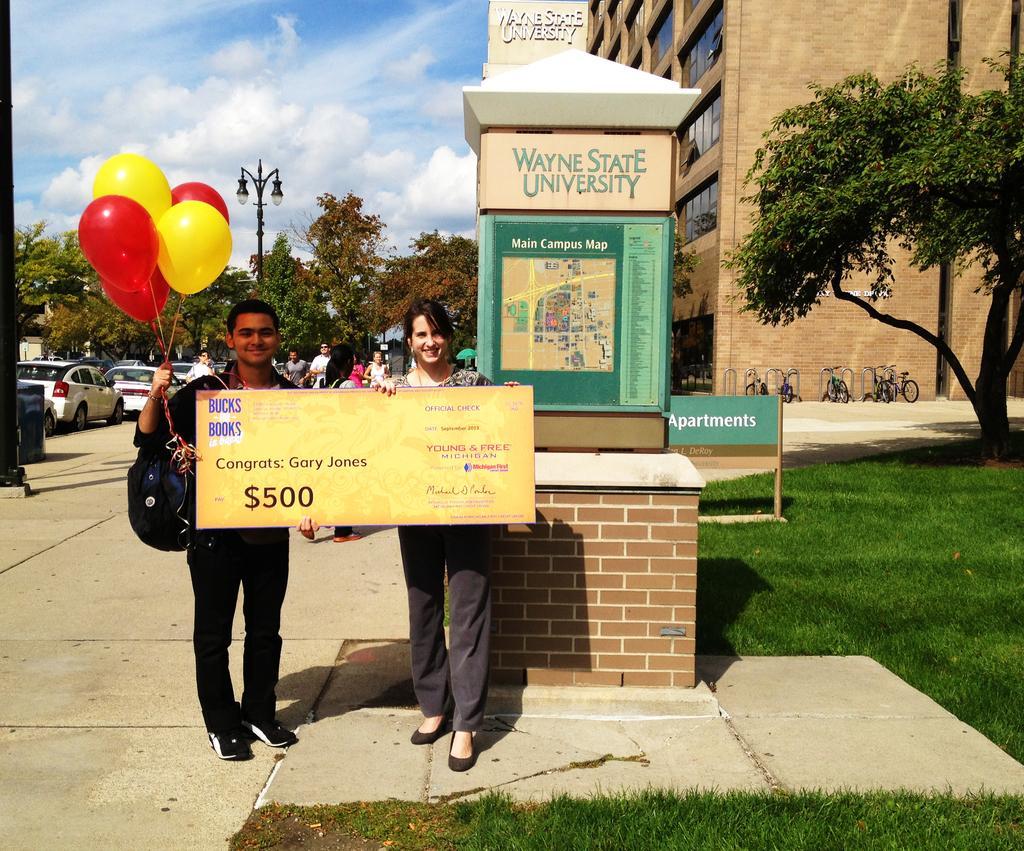Could you give a brief overview of what you see in this image? In this image I can see a woman is standing and holding the yellow color board in her hand and smiling. On the left side a man is smiling and holding the balloons in his hand, behind them there are cars and trees. On the right side there is a building, at the top it is the sky. 